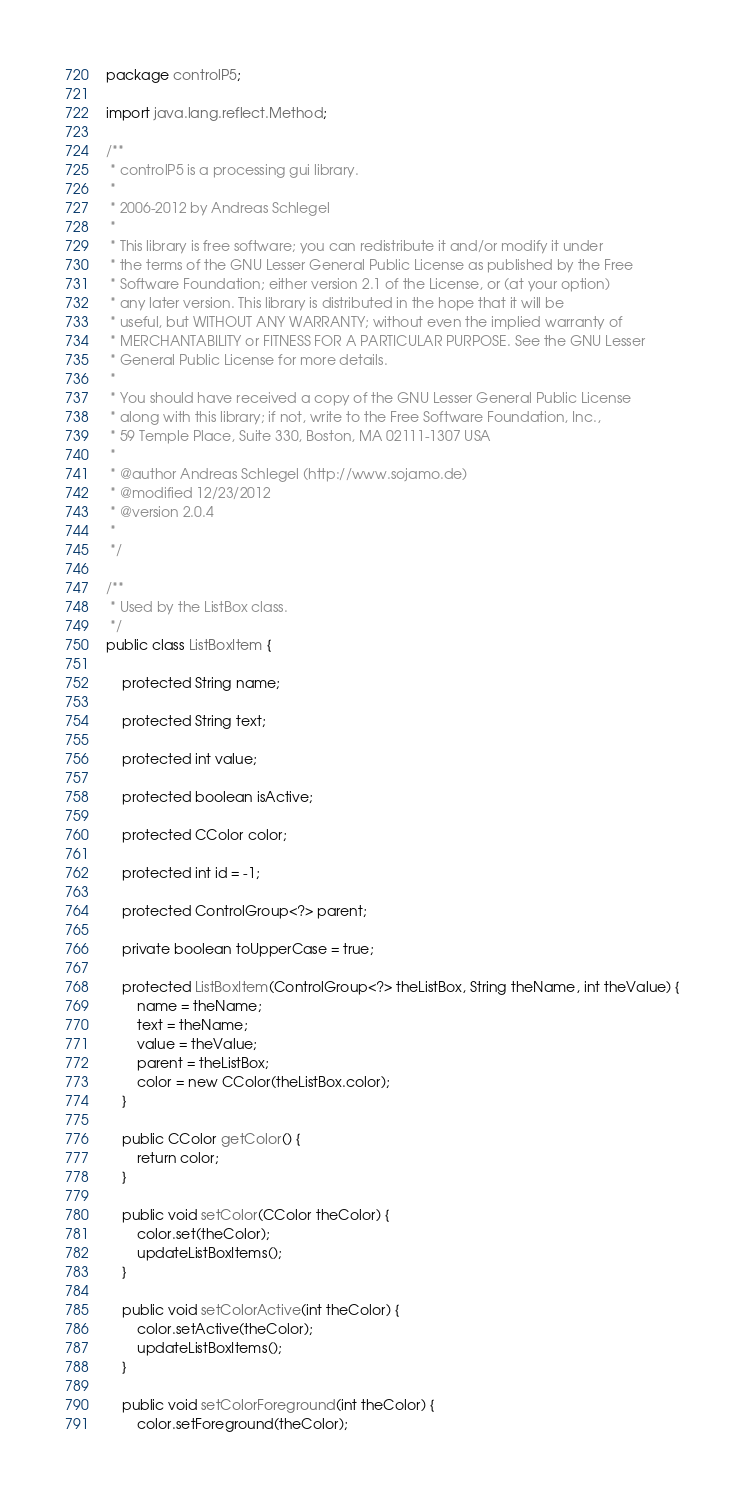Convert code to text. <code><loc_0><loc_0><loc_500><loc_500><_Java_>package controlP5;

import java.lang.reflect.Method;

/**
 * controlP5 is a processing gui library.
 * 
 * 2006-2012 by Andreas Schlegel
 * 
 * This library is free software; you can redistribute it and/or modify it under
 * the terms of the GNU Lesser General Public License as published by the Free
 * Software Foundation; either version 2.1 of the License, or (at your option)
 * any later version. This library is distributed in the hope that it will be
 * useful, but WITHOUT ANY WARRANTY; without even the implied warranty of
 * MERCHANTABILITY or FITNESS FOR A PARTICULAR PURPOSE. See the GNU Lesser
 * General Public License for more details.
 * 
 * You should have received a copy of the GNU Lesser General Public License
 * along with this library; if not, write to the Free Software Foundation, Inc.,
 * 59 Temple Place, Suite 330, Boston, MA 02111-1307 USA
 * 
 * @author Andreas Schlegel (http://www.sojamo.de)
 * @modified 12/23/2012
 * @version 2.0.4
 * 
 */

/**
 * Used by the ListBox class.
 */
public class ListBoxItem {

	protected String name;

	protected String text;

	protected int value;

	protected boolean isActive;

	protected CColor color;

	protected int id = -1;

	protected ControlGroup<?> parent;

	private boolean toUpperCase = true;

	protected ListBoxItem(ControlGroup<?> theListBox, String theName, int theValue) {
		name = theName;
		text = theName;
		value = theValue;
		parent = theListBox;
		color = new CColor(theListBox.color);
	}

	public CColor getColor() {
		return color;
	}

	public void setColor(CColor theColor) {
		color.set(theColor);
		updateListBoxItems();
	}

	public void setColorActive(int theColor) {
		color.setActive(theColor);
		updateListBoxItems();
	}

	public void setColorForeground(int theColor) {
		color.setForeground(theColor);</code> 